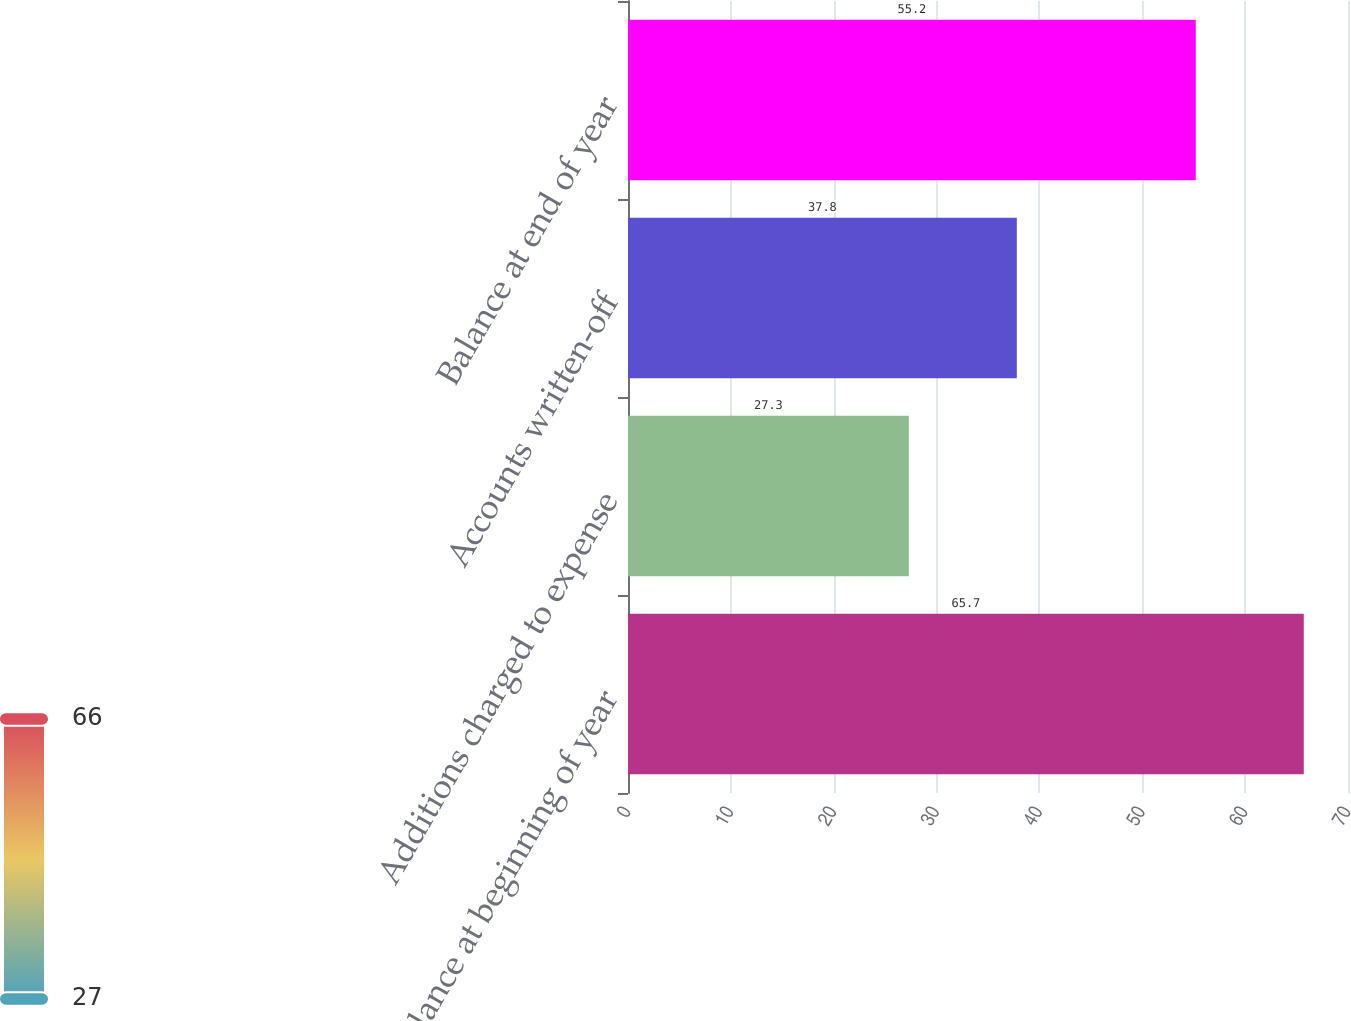Convert chart. <chart><loc_0><loc_0><loc_500><loc_500><bar_chart><fcel>Balance at beginning of year<fcel>Additions charged to expense<fcel>Accounts written-off<fcel>Balance at end of year<nl><fcel>65.7<fcel>27.3<fcel>37.8<fcel>55.2<nl></chart> 